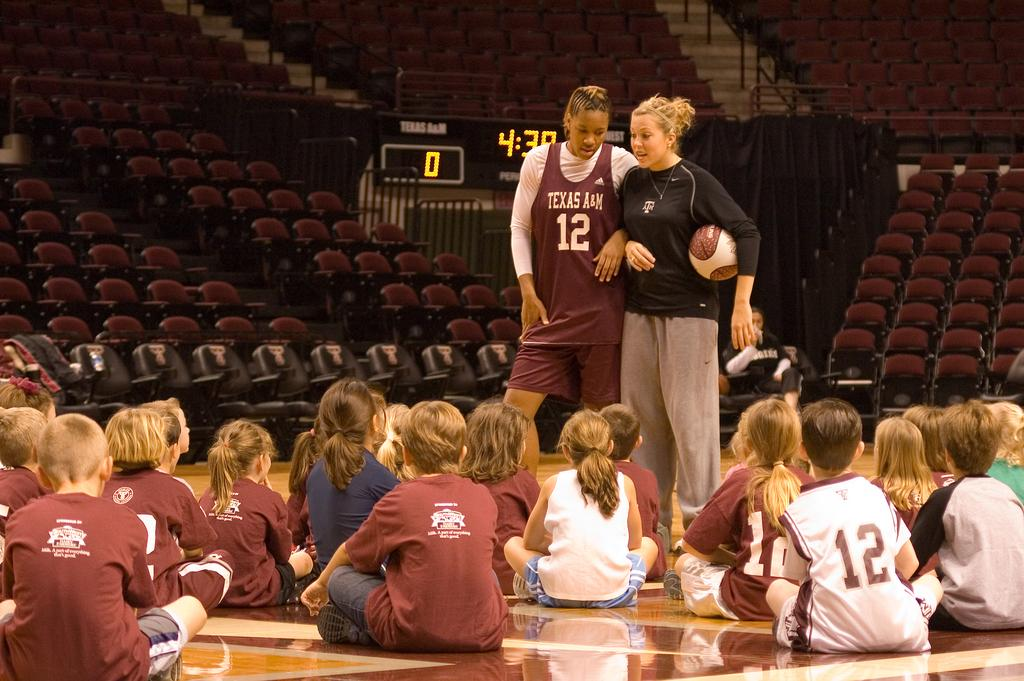What are the children in the image doing? The children are sitting on the floor in the image. How many women are standing in the image? There are 2 women standing in the image. What object is being held by a person in the image? A person is holding a ball in the image. What time-keeping device is present in the image? There is a digital clock in the image. What type of furniture is located at the back of the image? There are chairs at the back in the image. Is there a chain hanging from the ceiling in the image? No, there is no chain hanging from the ceiling in the image. How many boys are present in the image? The provided facts do not mention any boys in the image, only children. 